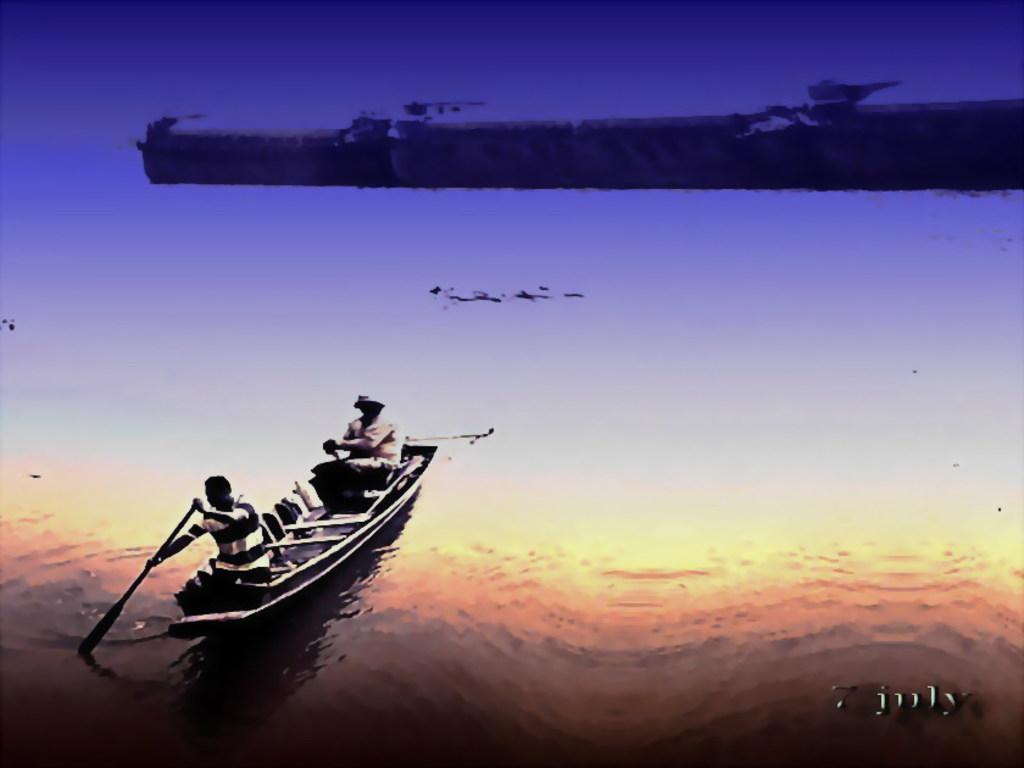Could you give a brief overview of what you see in this image? In this image there is water, there is a boat, there are two men rowing the boat, there is a wall towards the right of the image, there is text towards the bottom of the image, there is a number towards the bottom of the image. 